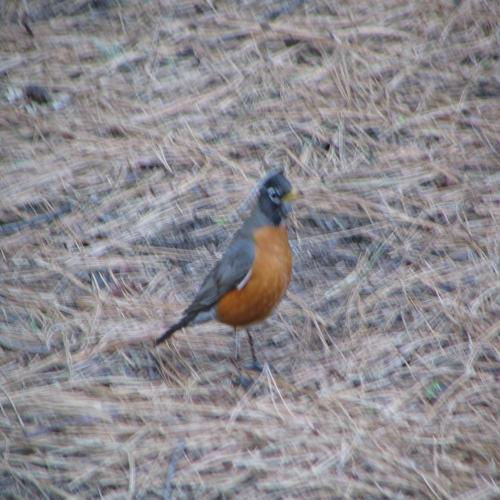Is there any indication of the current season in the image? The grassy ground is covered with dry, brown foliage, which may suggest that the photo was taken in the late summer or early fall when many plants begin to wither. The lighting is soft, lacking harsh shadows, which might indicate an overcast day or a time close to sunrise or sunset. 